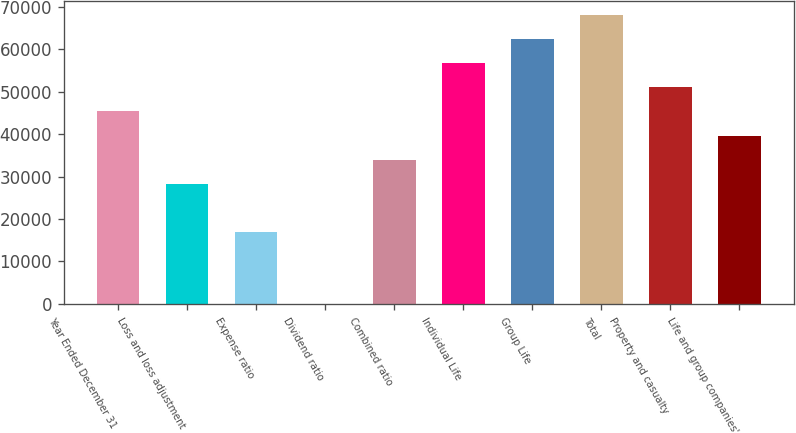Convert chart. <chart><loc_0><loc_0><loc_500><loc_500><bar_chart><fcel>Year Ended December 31<fcel>Loss and loss adjustment<fcel>Expense ratio<fcel>Dividend ratio<fcel>Combined ratio<fcel>Individual Life<fcel>Group Life<fcel>Total<fcel>Property and casualty<fcel>Life and group companies'<nl><fcel>45316<fcel>28322.6<fcel>16993.6<fcel>0.2<fcel>33987.1<fcel>56645<fcel>62309.5<fcel>67974<fcel>50980.5<fcel>39651.6<nl></chart> 